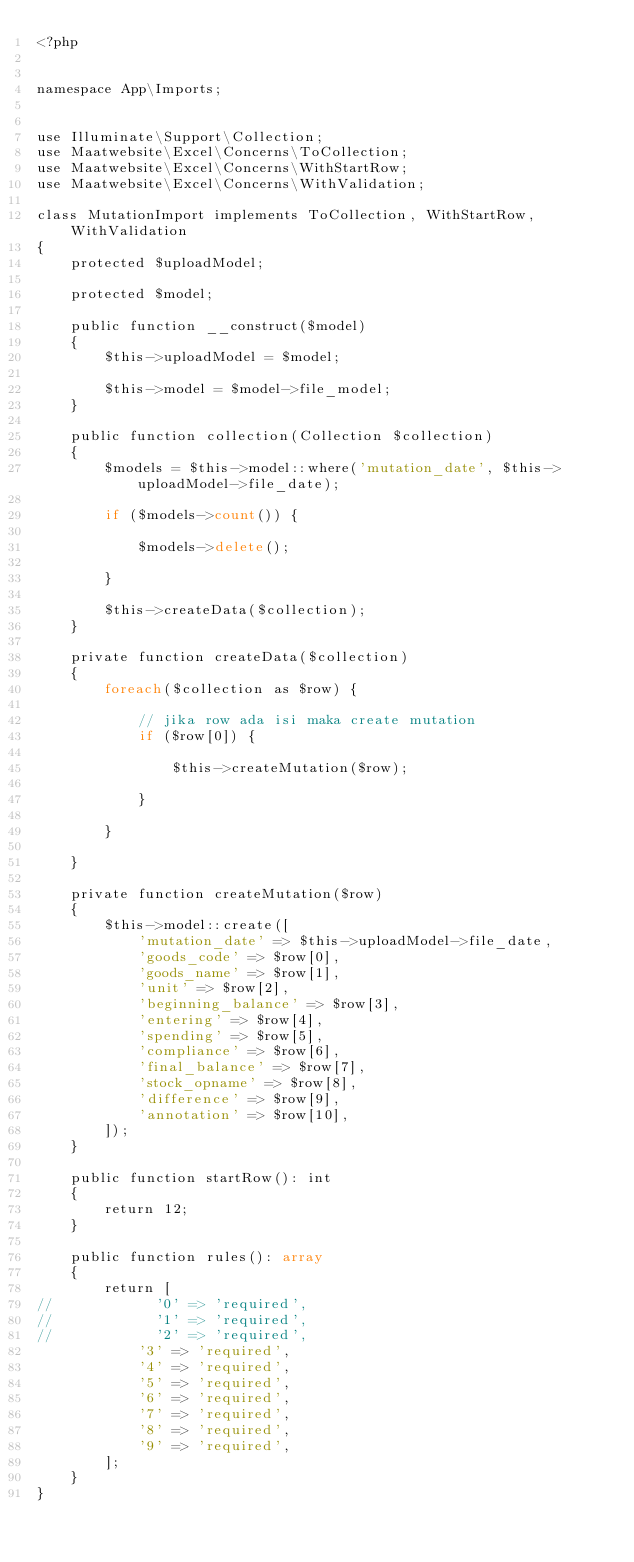<code> <loc_0><loc_0><loc_500><loc_500><_PHP_><?php


namespace App\Imports;


use Illuminate\Support\Collection;
use Maatwebsite\Excel\Concerns\ToCollection;
use Maatwebsite\Excel\Concerns\WithStartRow;
use Maatwebsite\Excel\Concerns\WithValidation;

class MutationImport implements ToCollection, WithStartRow, WithValidation
{
    protected $uploadModel;

    protected $model;

    public function __construct($model)
    {
        $this->uploadModel = $model;

        $this->model = $model->file_model;
    }

    public function collection(Collection $collection)
    {
        $models = $this->model::where('mutation_date', $this->uploadModel->file_date);

        if ($models->count()) {

            $models->delete();

        }

        $this->createData($collection);
    }

    private function createData($collection)
    {
        foreach($collection as $row) {

            // jika row ada isi maka create mutation
            if ($row[0]) {

                $this->createMutation($row);

            }

        }

    }

    private function createMutation($row)
    {
        $this->model::create([
            'mutation_date' => $this->uploadModel->file_date,
            'goods_code' => $row[0],
            'goods_name' => $row[1],
            'unit' => $row[2],
            'beginning_balance' => $row[3],
            'entering' => $row[4],
            'spending' => $row[5],
            'compliance' => $row[6],
            'final_balance' => $row[7],
            'stock_opname' => $row[8],
            'difference' => $row[9],
            'annotation' => $row[10],
        ]);
    }

    public function startRow(): int
    {
        return 12;
    }

    public function rules(): array
    {
        return [
//            '0' => 'required',
//            '1' => 'required',
//            '2' => 'required',
            '3' => 'required',
            '4' => 'required',
            '5' => 'required',
            '6' => 'required',
            '7' => 'required',
            '8' => 'required',
            '9' => 'required',
        ];
    }
}
</code> 